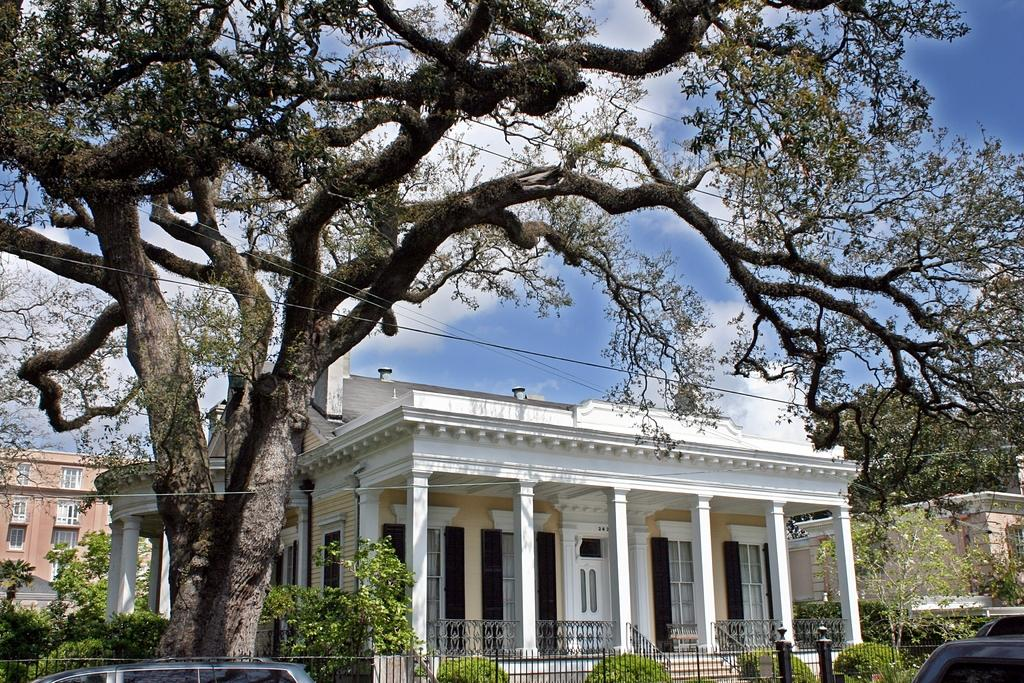What type of structures can be seen in the image? There are buildings in the image. What else can be seen in the image besides buildings? There are vehicles, plants, trees, windows, poles, pillars, wires, and a fence visible in the image. Can you describe the natural elements in the image? There are plants and trees in the image. What is visible in the background of the image? The sky is visible in the background of the image. What type of approval is required to start the spark in the image? There is no mention of approval, start, or spark in the image; it features buildings, vehicles, plants, trees, windows, poles, pillars, wires, and a fence. 